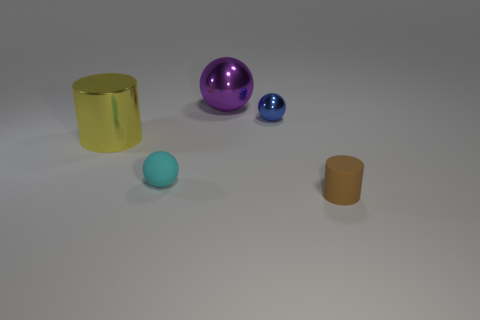Is the brown cylinder made of the same material as the large yellow thing?
Give a very brief answer. No. There is a yellow object that is the same shape as the tiny brown thing; what size is it?
Offer a very short reply. Large. How many objects are objects that are behind the tiny metallic sphere or tiny things on the left side of the small brown thing?
Give a very brief answer. 3. Are there fewer small blue metal balls than big brown matte spheres?
Offer a terse response. No. Does the blue sphere have the same size as the rubber object that is left of the small blue thing?
Your response must be concise. Yes. How many rubber objects are either brown objects or yellow things?
Your answer should be very brief. 1. Are there more blue metal balls than large metal things?
Provide a short and direct response. No. What is the shape of the thing that is in front of the tiny cyan ball that is in front of the purple shiny ball?
Provide a succinct answer. Cylinder. There is a tiny cylinder that is in front of the big shiny object behind the large shiny cylinder; is there a brown cylinder to the right of it?
Your answer should be very brief. No. There is a metal ball that is the same size as the brown object; what is its color?
Your answer should be compact. Blue. 